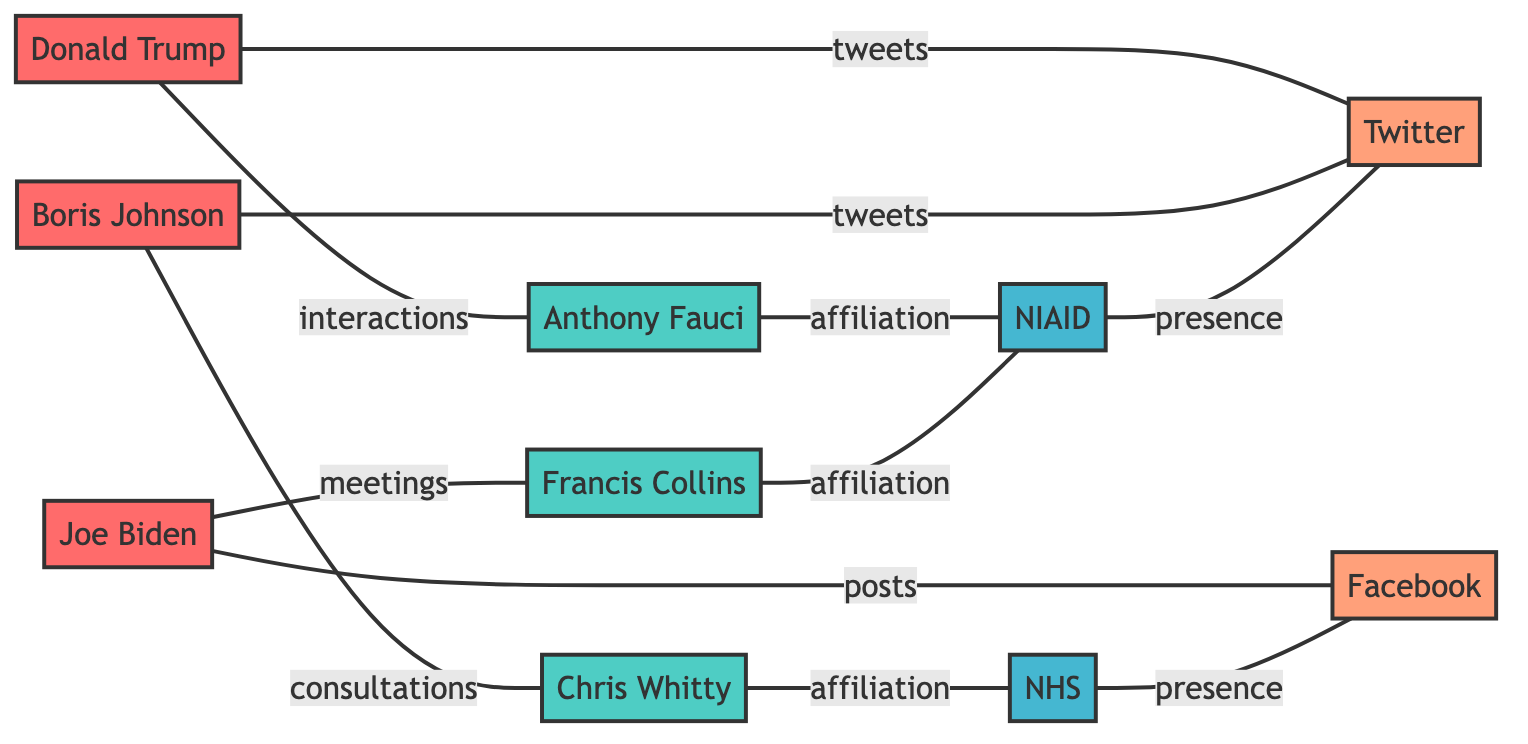What politician interacts with Anthony Fauci? By examining the connections in the diagram, we see that Donald Trump is linked to Anthony Fauci with the label "interactions." Therefore, Donald Trump is the politician who interacts with Anthony Fauci.
Answer: Donald Trump How many scientists are represented in the diagram? The diagram includes three scientists (Anthony Fauci, Francis Collins, and Chris Whitty). By counting the nodes labeled as "scientist," we find that there are three.
Answer: 3 Which social media platform is associated with Boris Johnson? The connection shows that Boris Johnson is linked to Twitter with the label "tweets." This indicates that the primary social media platform associated with Boris Johnson in the diagram is Twitter.
Answer: Twitter What is the affiliation of Francis Collins? The edge from Francis Collins points to NIAID with the label "affiliation," indicating that his affiliated organization is NIAID.
Answer: NIAID Which organization is linked to Chris Whitty? The diagram shows that Chris Whitty is connected to NHS with the label "affiliation." This means that the organization associated with Chris Whitty is NHS.
Answer: NHS Who posts on Facebook? By looking at the connections, Joe Biden is linked to Facebook with the label "posts." Thus, Joe Biden is responsible for posting on Facebook.
Answer: Joe Biden What type of relationship exists between Donald Trump and Twitter? The connection between Donald Trump and Twitter is labeled "tweets," indicating that the relationship type here is one of tweeting.
Answer: tweets How many total edges are there in the diagram? Counting all the edges directly from the diagram, we see that there are ten connections between nodes. Therefore, the total number of edges in the diagram is ten.
Answer: 10 What organization has a presence on Twitter? The link shows that NIAID is associated with Twitter through the label "presence," meaning that NIAID has a presence on the Twitter platform.
Answer: NIAID 